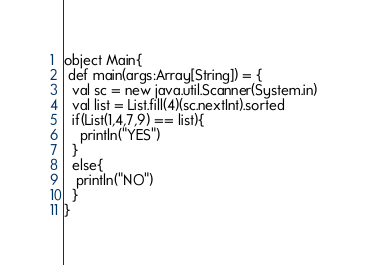<code> <loc_0><loc_0><loc_500><loc_500><_Scala_>object Main{
 def main(args:Array[String]) = {
  val sc = new java.util.Scanner(System.in)
  val list = List.fill(4)(sc.nextInt).sorted
  if(List(1,4,7,9) == list){
    println("YES")
  }
  else{
   println("NO")
  }
}</code> 